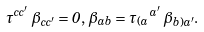Convert formula to latex. <formula><loc_0><loc_0><loc_500><loc_500>\tau ^ { c c ^ { \prime } } \, \beta _ { c c ^ { \prime } } = 0 , \, \beta _ { a b } = \tau _ { ( a } \, ^ { a ^ { \prime } } \, \beta _ { b ) a ^ { \prime } } .</formula> 